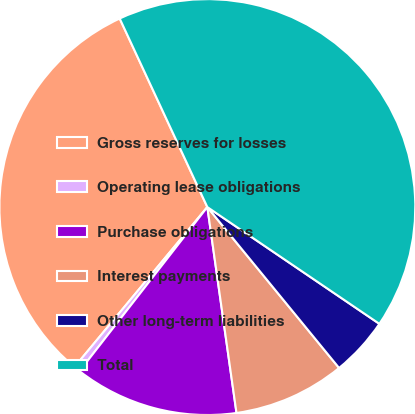<chart> <loc_0><loc_0><loc_500><loc_500><pie_chart><fcel>Gross reserves for losses<fcel>Operating lease obligations<fcel>Purchase obligations<fcel>Interest payments<fcel>Other long-term liabilities<fcel>Total<nl><fcel>32.04%<fcel>0.5%<fcel>12.77%<fcel>8.68%<fcel>4.59%<fcel>41.41%<nl></chart> 